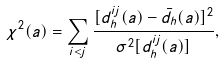<formula> <loc_0><loc_0><loc_500><loc_500>\chi ^ { 2 } ( a ) = \sum _ { i < j } \frac { [ d _ { h } ^ { i j } ( a ) - \bar { d } _ { h } ( a ) ] ^ { 2 } } { \sigma ^ { 2 } [ d _ { h } ^ { i j } ( a ) ] } ,</formula> 